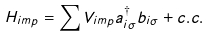<formula> <loc_0><loc_0><loc_500><loc_500>H _ { i m p } = \sum V _ { i m p } a ^ { \dagger } _ { i \sigma } b _ { i \sigma } + c . c .</formula> 